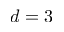<formula> <loc_0><loc_0><loc_500><loc_500>d = 3</formula> 